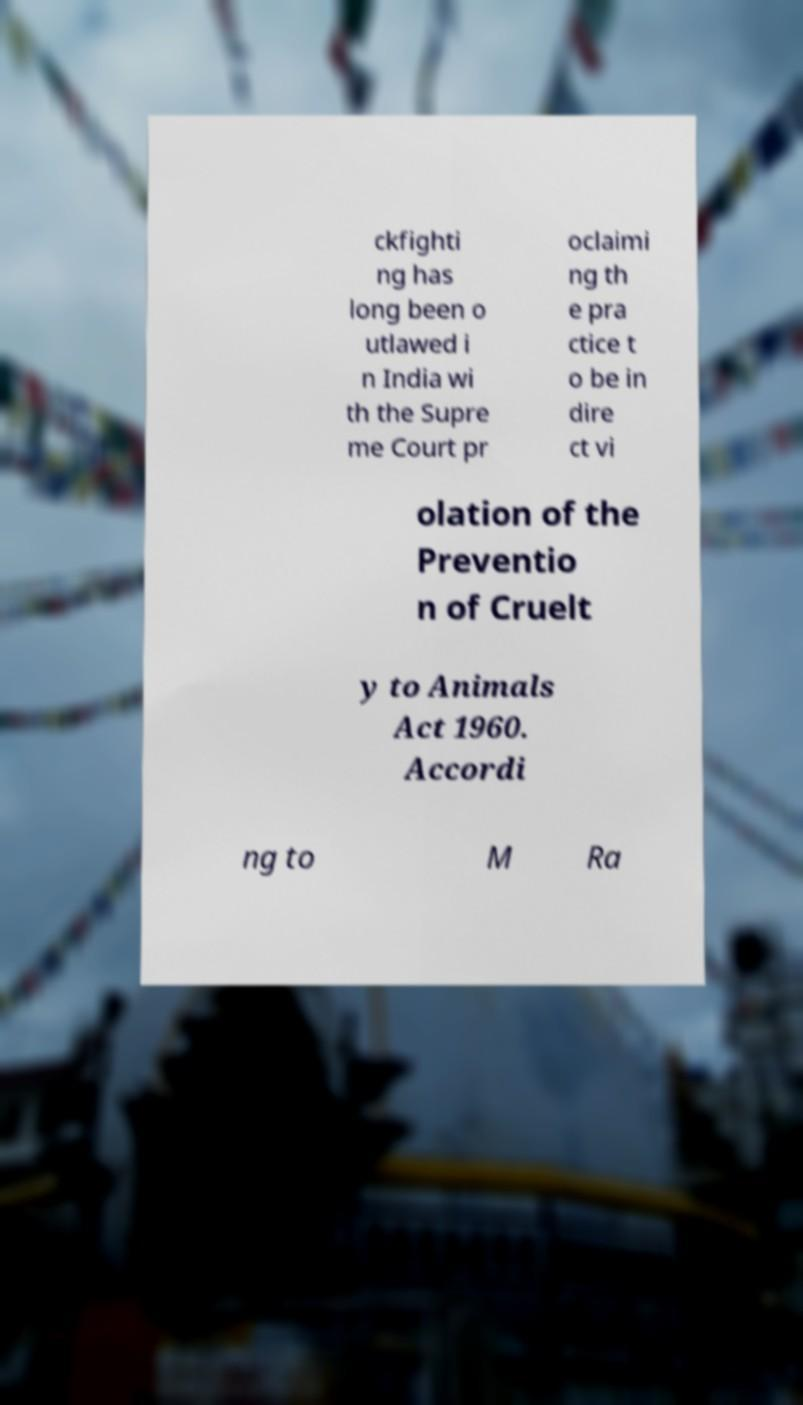Please read and relay the text visible in this image. What does it say? ckfighti ng has long been o utlawed i n India wi th the Supre me Court pr oclaimi ng th e pra ctice t o be in dire ct vi olation of the Preventio n of Cruelt y to Animals Act 1960. Accordi ng to M Ra 